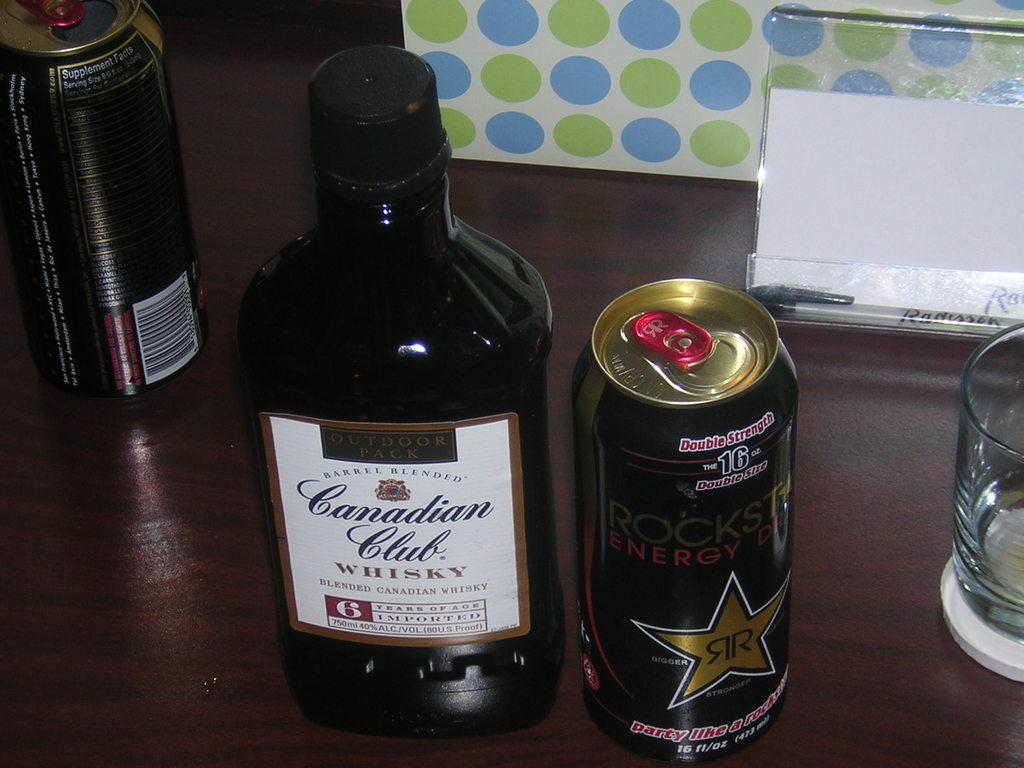<image>
Create a compact narrative representing the image presented. A can of Rockstar and bottle of Canadian Club. 